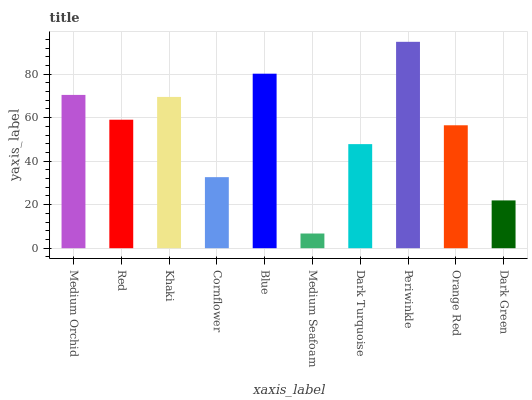Is Red the minimum?
Answer yes or no. No. Is Red the maximum?
Answer yes or no. No. Is Medium Orchid greater than Red?
Answer yes or no. Yes. Is Red less than Medium Orchid?
Answer yes or no. Yes. Is Red greater than Medium Orchid?
Answer yes or no. No. Is Medium Orchid less than Red?
Answer yes or no. No. Is Red the high median?
Answer yes or no. Yes. Is Orange Red the low median?
Answer yes or no. Yes. Is Medium Orchid the high median?
Answer yes or no. No. Is Periwinkle the low median?
Answer yes or no. No. 